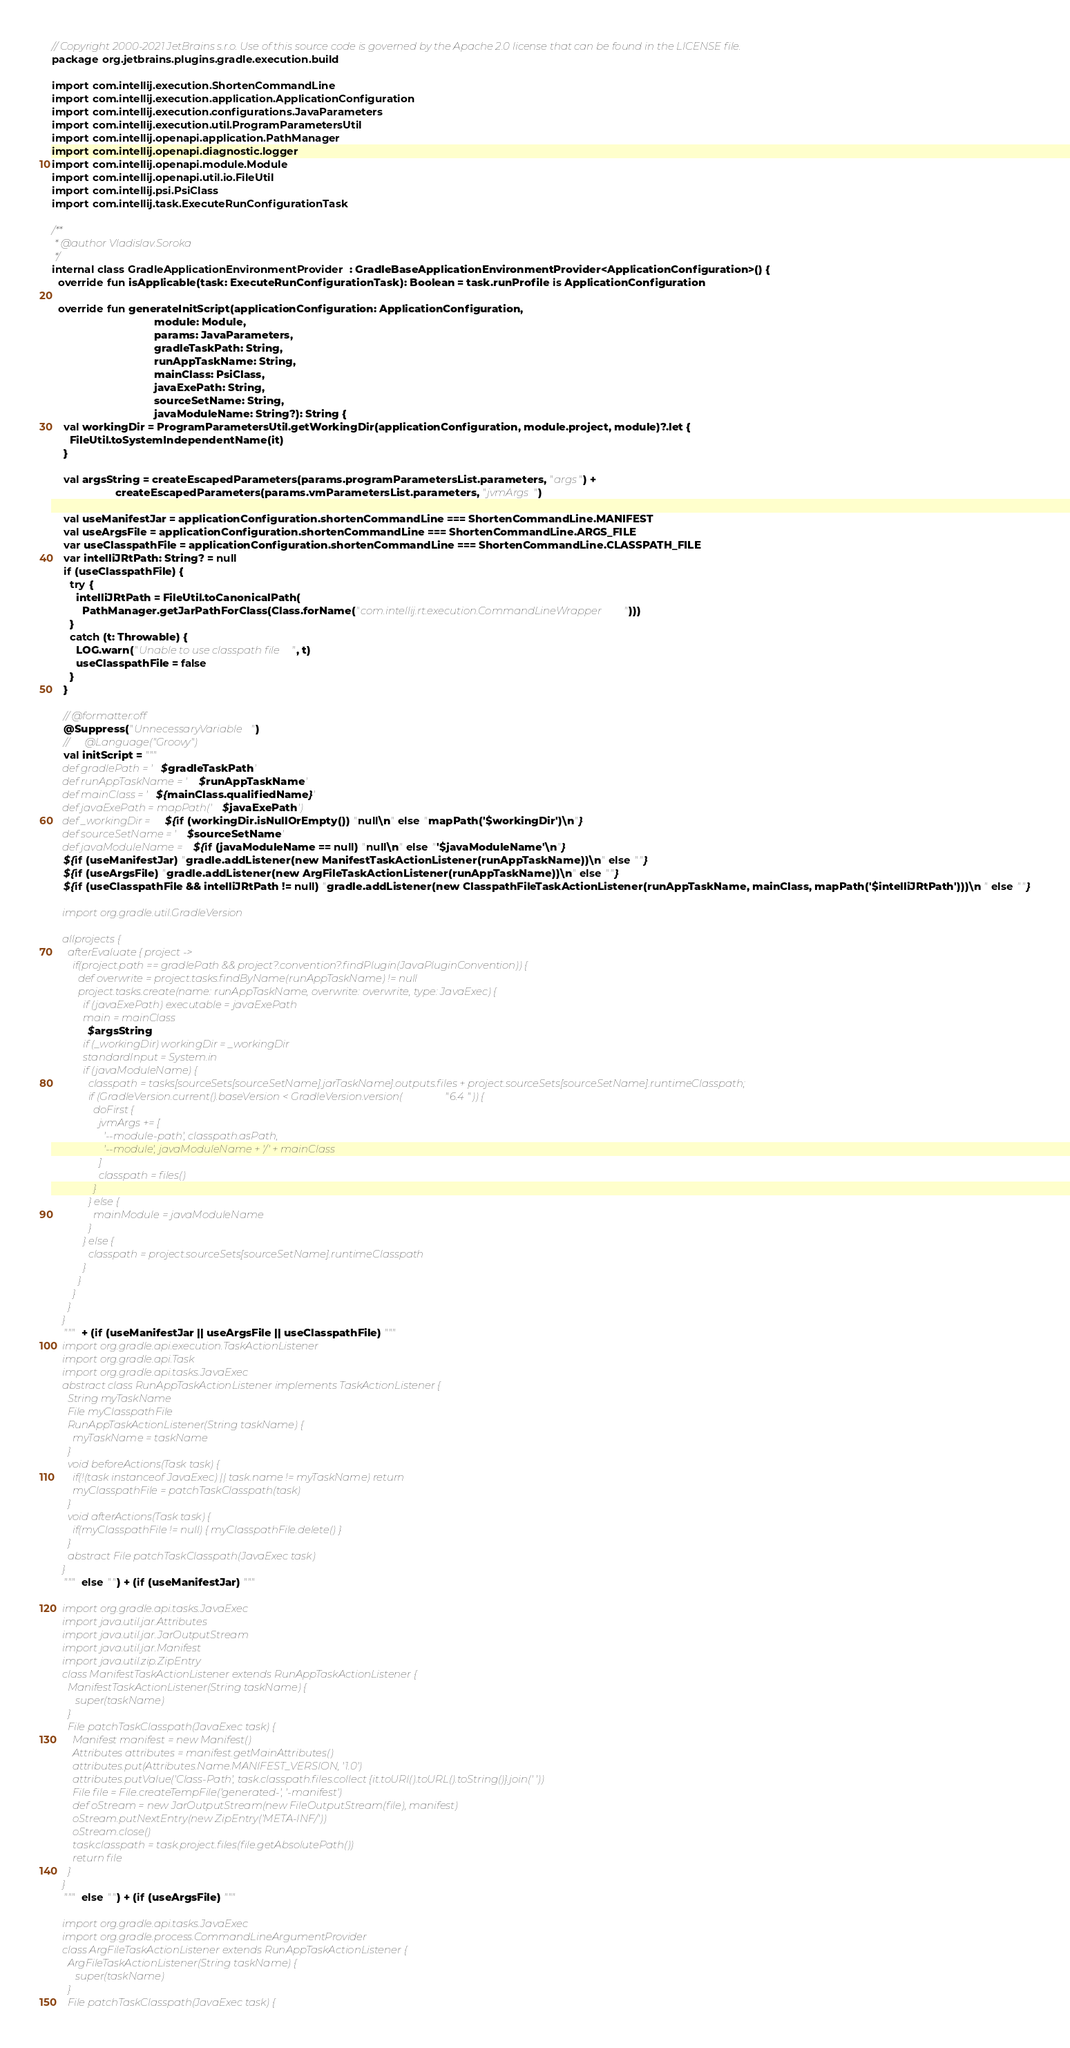<code> <loc_0><loc_0><loc_500><loc_500><_Kotlin_>// Copyright 2000-2021 JetBrains s.r.o. Use of this source code is governed by the Apache 2.0 license that can be found in the LICENSE file.
package org.jetbrains.plugins.gradle.execution.build

import com.intellij.execution.ShortenCommandLine
import com.intellij.execution.application.ApplicationConfiguration
import com.intellij.execution.configurations.JavaParameters
import com.intellij.execution.util.ProgramParametersUtil
import com.intellij.openapi.application.PathManager
import com.intellij.openapi.diagnostic.logger
import com.intellij.openapi.module.Module
import com.intellij.openapi.util.io.FileUtil
import com.intellij.psi.PsiClass
import com.intellij.task.ExecuteRunConfigurationTask

/**
 * @author Vladislav.Soroka
 */
internal class GradleApplicationEnvironmentProvider : GradleBaseApplicationEnvironmentProvider<ApplicationConfiguration>() {
  override fun isApplicable(task: ExecuteRunConfigurationTask): Boolean = task.runProfile is ApplicationConfiguration

  override fun generateInitScript(applicationConfiguration: ApplicationConfiguration,
                                  module: Module,
                                  params: JavaParameters,
                                  gradleTaskPath: String,
                                  runAppTaskName: String,
                                  mainClass: PsiClass,
                                  javaExePath: String,
                                  sourceSetName: String,
                                  javaModuleName: String?): String {
    val workingDir = ProgramParametersUtil.getWorkingDir(applicationConfiguration, module.project, module)?.let {
      FileUtil.toSystemIndependentName(it)
    }

    val argsString = createEscapedParameters(params.programParametersList.parameters, "args") +
                     createEscapedParameters(params.vmParametersList.parameters, "jvmArgs")

    val useManifestJar = applicationConfiguration.shortenCommandLine === ShortenCommandLine.MANIFEST
    val useArgsFile = applicationConfiguration.shortenCommandLine === ShortenCommandLine.ARGS_FILE
    var useClasspathFile = applicationConfiguration.shortenCommandLine === ShortenCommandLine.CLASSPATH_FILE
    var intelliJRtPath: String? = null
    if (useClasspathFile) {
      try {
        intelliJRtPath = FileUtil.toCanonicalPath(
          PathManager.getJarPathForClass(Class.forName("com.intellij.rt.execution.CommandLineWrapper")))
      }
      catch (t: Throwable) {
        LOG.warn("Unable to use classpath file", t)
        useClasspathFile = false
      }
    }

    // @formatter:off
    @Suppress("UnnecessaryVariable")
    //      @Language("Groovy")
    val initScript = """
    def gradlePath = '$gradleTaskPath'
    def runAppTaskName = '$runAppTaskName'
    def mainClass = '${mainClass.qualifiedName}'
    def javaExePath = mapPath('$javaExePath')
    def _workingDir = ${if (workingDir.isNullOrEmpty()) "null\n" else "mapPath('$workingDir')\n"}
    def sourceSetName = '$sourceSetName'
    def javaModuleName = ${if (javaModuleName == null) "null\n" else "'$javaModuleName'\n"}
    ${if (useManifestJar) "gradle.addListener(new ManifestTaskActionListener(runAppTaskName))\n" else ""}
    ${if (useArgsFile) "gradle.addListener(new ArgFileTaskActionListener(runAppTaskName))\n" else ""}
    ${if (useClasspathFile && intelliJRtPath != null) "gradle.addListener(new ClasspathFileTaskActionListener(runAppTaskName, mainClass, mapPath('$intelliJRtPath')))\n " else ""}

    import org.gradle.util.GradleVersion

    allprojects {
      afterEvaluate { project ->
        if(project.path == gradlePath && project?.convention?.findPlugin(JavaPluginConvention)) {
          def overwrite = project.tasks.findByName(runAppTaskName) != null
          project.tasks.create(name: runAppTaskName, overwrite: overwrite, type: JavaExec) {
            if (javaExePath) executable = javaExePath
            main = mainClass
            $argsString
            if (_workingDir) workingDir = _workingDir
            standardInput = System.in
            if (javaModuleName) {
              classpath = tasks[sourceSets[sourceSetName].jarTaskName].outputs.files + project.sourceSets[sourceSetName].runtimeClasspath;
              if (GradleVersion.current().baseVersion < GradleVersion.version("6.4")) {
                doFirst {
                  jvmArgs += [
                    '--module-path', classpath.asPath,
                    '--module', javaModuleName + '/' + mainClass
                  ]
                  classpath = files()
                }
              } else {
                mainModule = javaModuleName
              }
            } else {
              classpath = project.sourceSets[sourceSetName].runtimeClasspath
            }
          }
        }
      }
    }
    """ + (if (useManifestJar || useArgsFile || useClasspathFile) """
    import org.gradle.api.execution.TaskActionListener
    import org.gradle.api.Task
    import org.gradle.api.tasks.JavaExec
    abstract class RunAppTaskActionListener implements TaskActionListener {
      String myTaskName
      File myClasspathFile
      RunAppTaskActionListener(String taskName) {
        myTaskName = taskName
      }
      void beforeActions(Task task) {
        if(!(task instanceof JavaExec) || task.name != myTaskName) return
        myClasspathFile = patchTaskClasspath(task)
      }
      void afterActions(Task task) {
        if(myClasspathFile != null) { myClasspathFile.delete() }
      }
      abstract File patchTaskClasspath(JavaExec task)
    }
    """ else "") + (if (useManifestJar) """

    import org.gradle.api.tasks.JavaExec
    import java.util.jar.Attributes
    import java.util.jar.JarOutputStream
    import java.util.jar.Manifest
    import java.util.zip.ZipEntry
    class ManifestTaskActionListener extends RunAppTaskActionListener {
      ManifestTaskActionListener(String taskName) {
         super(taskName)
      }
      File patchTaskClasspath(JavaExec task) {
        Manifest manifest = new Manifest()
        Attributes attributes = manifest.getMainAttributes()
        attributes.put(Attributes.Name.MANIFEST_VERSION, '1.0')
        attributes.putValue('Class-Path', task.classpath.files.collect {it.toURI().toURL().toString()}.join(' '))
        File file = File.createTempFile('generated-', '-manifest')
        def oStream = new JarOutputStream(new FileOutputStream(file), manifest)
        oStream.putNextEntry(new ZipEntry('META-INF/'))
        oStream.close()
        task.classpath = task.project.files(file.getAbsolutePath())
        return file
      }
    }
    """ else "") + (if (useArgsFile) """

    import org.gradle.api.tasks.JavaExec
    import org.gradle.process.CommandLineArgumentProvider
    class ArgFileTaskActionListener extends RunAppTaskActionListener {
      ArgFileTaskActionListener(String taskName) {
         super(taskName)
      }
      File patchTaskClasspath(JavaExec task) {</code> 